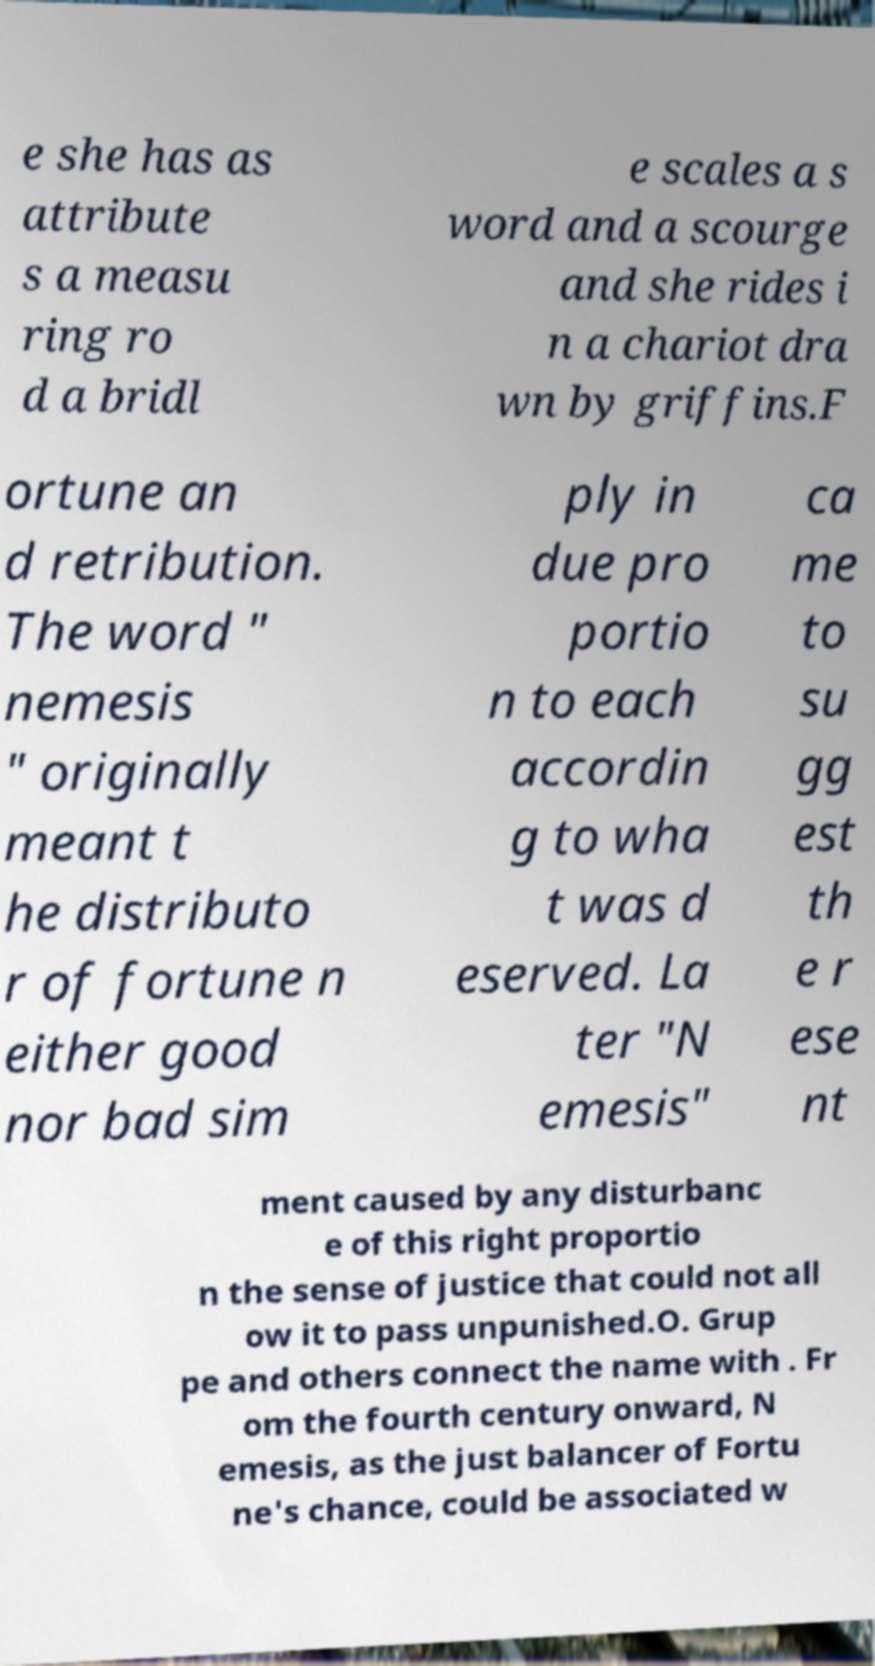Could you assist in decoding the text presented in this image and type it out clearly? e she has as attribute s a measu ring ro d a bridl e scales a s word and a scourge and she rides i n a chariot dra wn by griffins.F ortune an d retribution. The word " nemesis " originally meant t he distributo r of fortune n either good nor bad sim ply in due pro portio n to each accordin g to wha t was d eserved. La ter "N emesis" ca me to su gg est th e r ese nt ment caused by any disturbanc e of this right proportio n the sense of justice that could not all ow it to pass unpunished.O. Grup pe and others connect the name with . Fr om the fourth century onward, N emesis, as the just balancer of Fortu ne's chance, could be associated w 